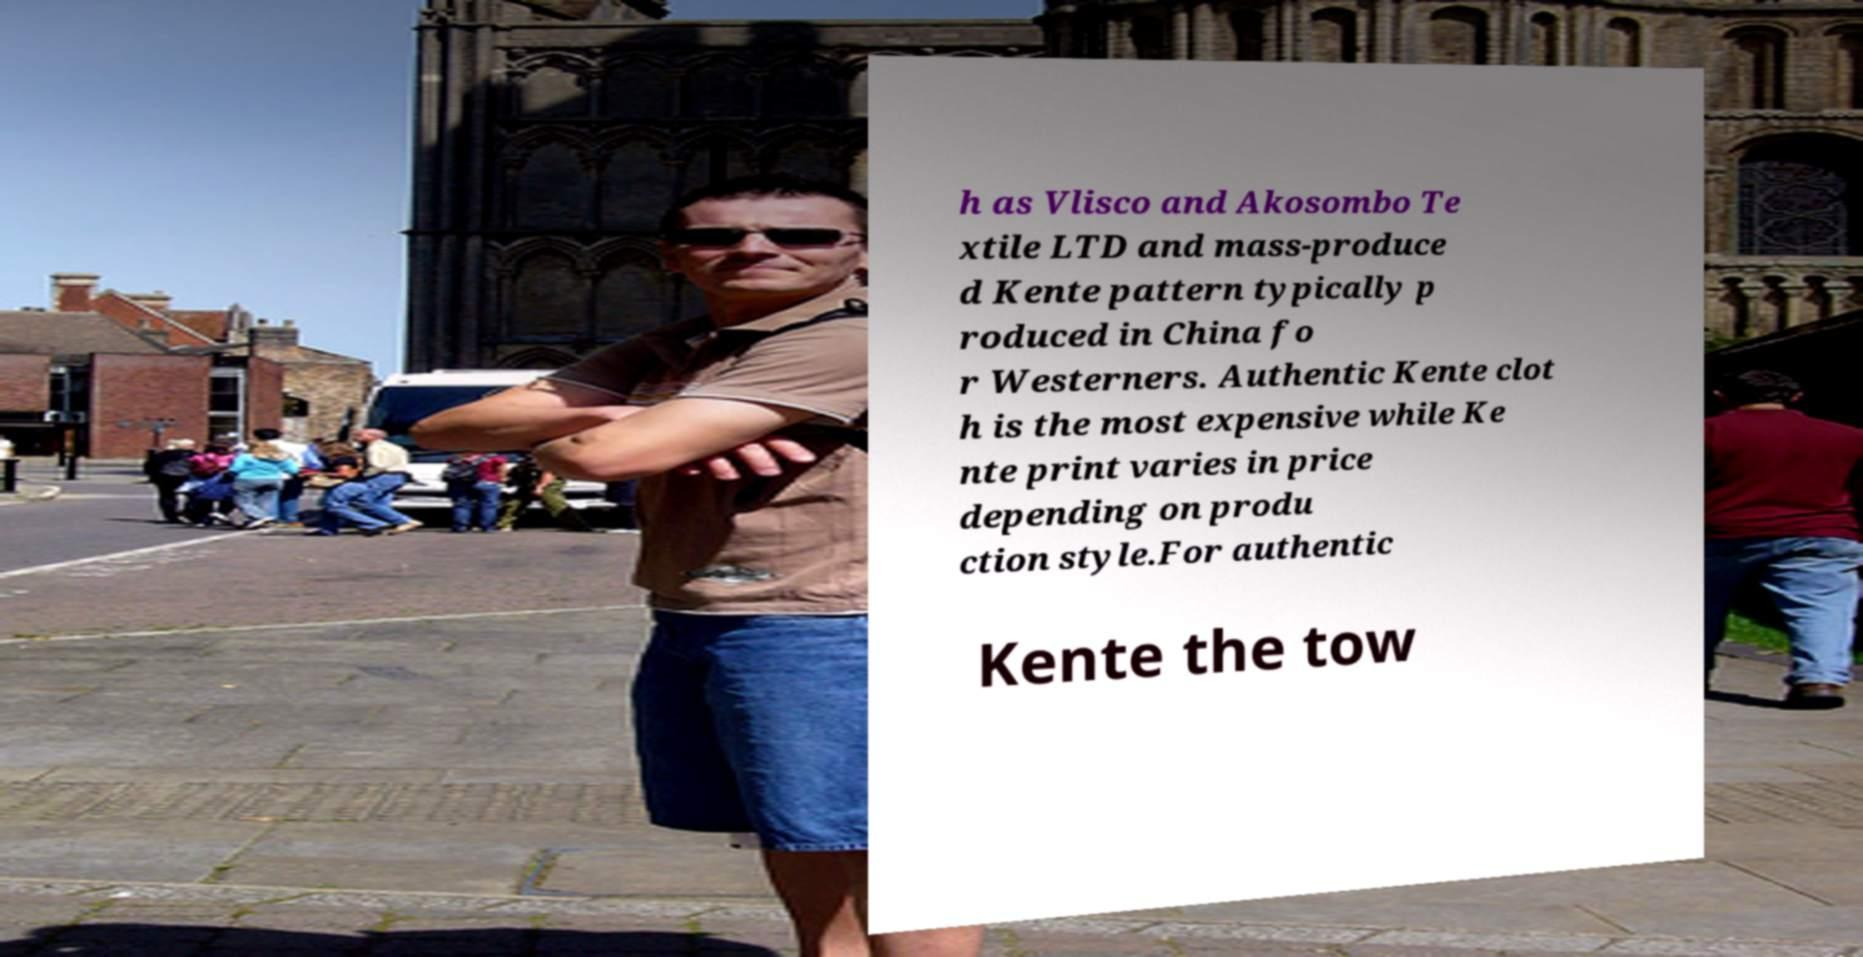Can you read and provide the text displayed in the image?This photo seems to have some interesting text. Can you extract and type it out for me? h as Vlisco and Akosombo Te xtile LTD and mass-produce d Kente pattern typically p roduced in China fo r Westerners. Authentic Kente clot h is the most expensive while Ke nte print varies in price depending on produ ction style.For authentic Kente the tow 